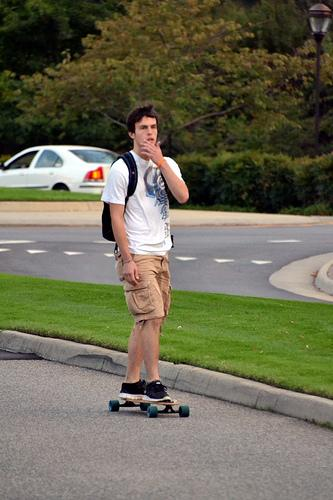Give me a short description of the scene in the image. A young boy is riding a skateboard with blue wheels on a gray road near a white car, wearing tan shorts and a white t-shirt. Analyze the possible interaction between the boy and the white car in the image. The boy is skateboarding on the street near the parked car but doesn't seem to be directly interacting with it. How would you describe the overall sentiment or emotion of the image? The image has a positive and energetic vibe, showing a young boy enjoying himself while riding a skateboard. Describe the street on which the young boy is skateboarding. The street is gray with white lines, and there's a curb with a tire mark and a white car parked nearby. Count the number of blue skateboard wheels visible in the image. There are four blue skateboard wheels visible in the image. What kind of vehicle is present in the image, and where is it located? A white car is parked in a parking space, located to the left of the boy. What is the boy's right wrist adorned with?  The boy is wearing a band around his right wrist. Can you identify any interesting features about the boy's outfit?  The boy is wearing black and white tennis shoes, a white t-shirt with a gray and blue design, and tan shorts. He also has an orange band on his left wrist and a backpack on his back. What color are the skateboard's wheels? The skateboard's wheels are blue. Is there any object in the background that stands out? A lamp post standing on the other side of a hedge stands out in the background. Is there a stop sign on top of the lamp post standing on the other side of the hedge? None of the given captions refer to a stop sign attached to the lamp post. This instruction is misleading because it adds an extra element that doesn't exist in the image. Is the young boy wearing red tennis shoes while skateboarding? The actual caption indicates that the young boy is wearing black tennis shoes, not red ones. This is misleading because it gives the wrong color for the shoes. Detect the sentiment portrayed in the image. Active, adventurous, and fun. Find the location of the light pole in relation to the bushes. The light pole is behind the bushes. Mention the position of the young boy's backpack. The backpack is on the boy's back. Can you find the skateboard with pink wheels under the boy's feet? The actual skateboard mentioned in the image has blue wheels, not pink ones. This instruction is misleading because it falsely implies that the wheels might be different in color. Is the young boy wearing a black and white shoe or a black and blue shoe? The young boy is wearing a black and white shoe. Are there any anomalies or unusual objects in the image? No, there are no anomalies or unusual objects. Do the white lines on the road seem to have any specific meaning? Yes, the white lines mark lanes or borders on the road. Is there a purple car parked in the parking space instead of a white car? The actual caption states that there's a white car in the parking space. This instruction misleadingly suggests that a purple car might be there instead. Is the man carrying a bright green backpack on his back? The captions indicate that the man is carrying a black backpack, not a bright green one. This instruction is misleading because it mentions a completely different color for the existing object. Which way is the white car going in the image? The white car is driving away. What type of wristband is the young boy wearing on his right wrist? The young boy is wearing an orange wristband on his left wrist. What are the triangles on the road made of? White lines Describe the main activity of the young boy in the image. The young boy is riding on a skateboard. Which object in the image has a tire mark on it? Curb Describe the appearance of the road in the image. The road is gray with white lines and white triangles. Identify the objects in the image that are being used for transportation. White car, skateboard. Which object in the image is interacting with the lamp post? No object is directly interacting with the lamp post. Does the young boy have blonde hair while riding the skateboard? The actual caption mentions that the guy has dark hair. This instruction gives incorrect information about the boy's hair color, making it misleading. How is the parking space indicated in the image? There is a white car parked in the parking space. From the items visible in the image, identify the young boy's attire. The young boy is dressed in a white t-shirt, tan shorts, and black tennis shoes. Identify the prominent color of the skateboard wheels in the image. The skateboard wheels are blue. Discuss the presence and position of the black backpack in the image. The black backpack is present on the young boy's back. How would you rate the image quality, on a scale of 1 to 10? 8 List the visible attributes of the skateboard in the image. White, blue wheels, under boy's feet. 